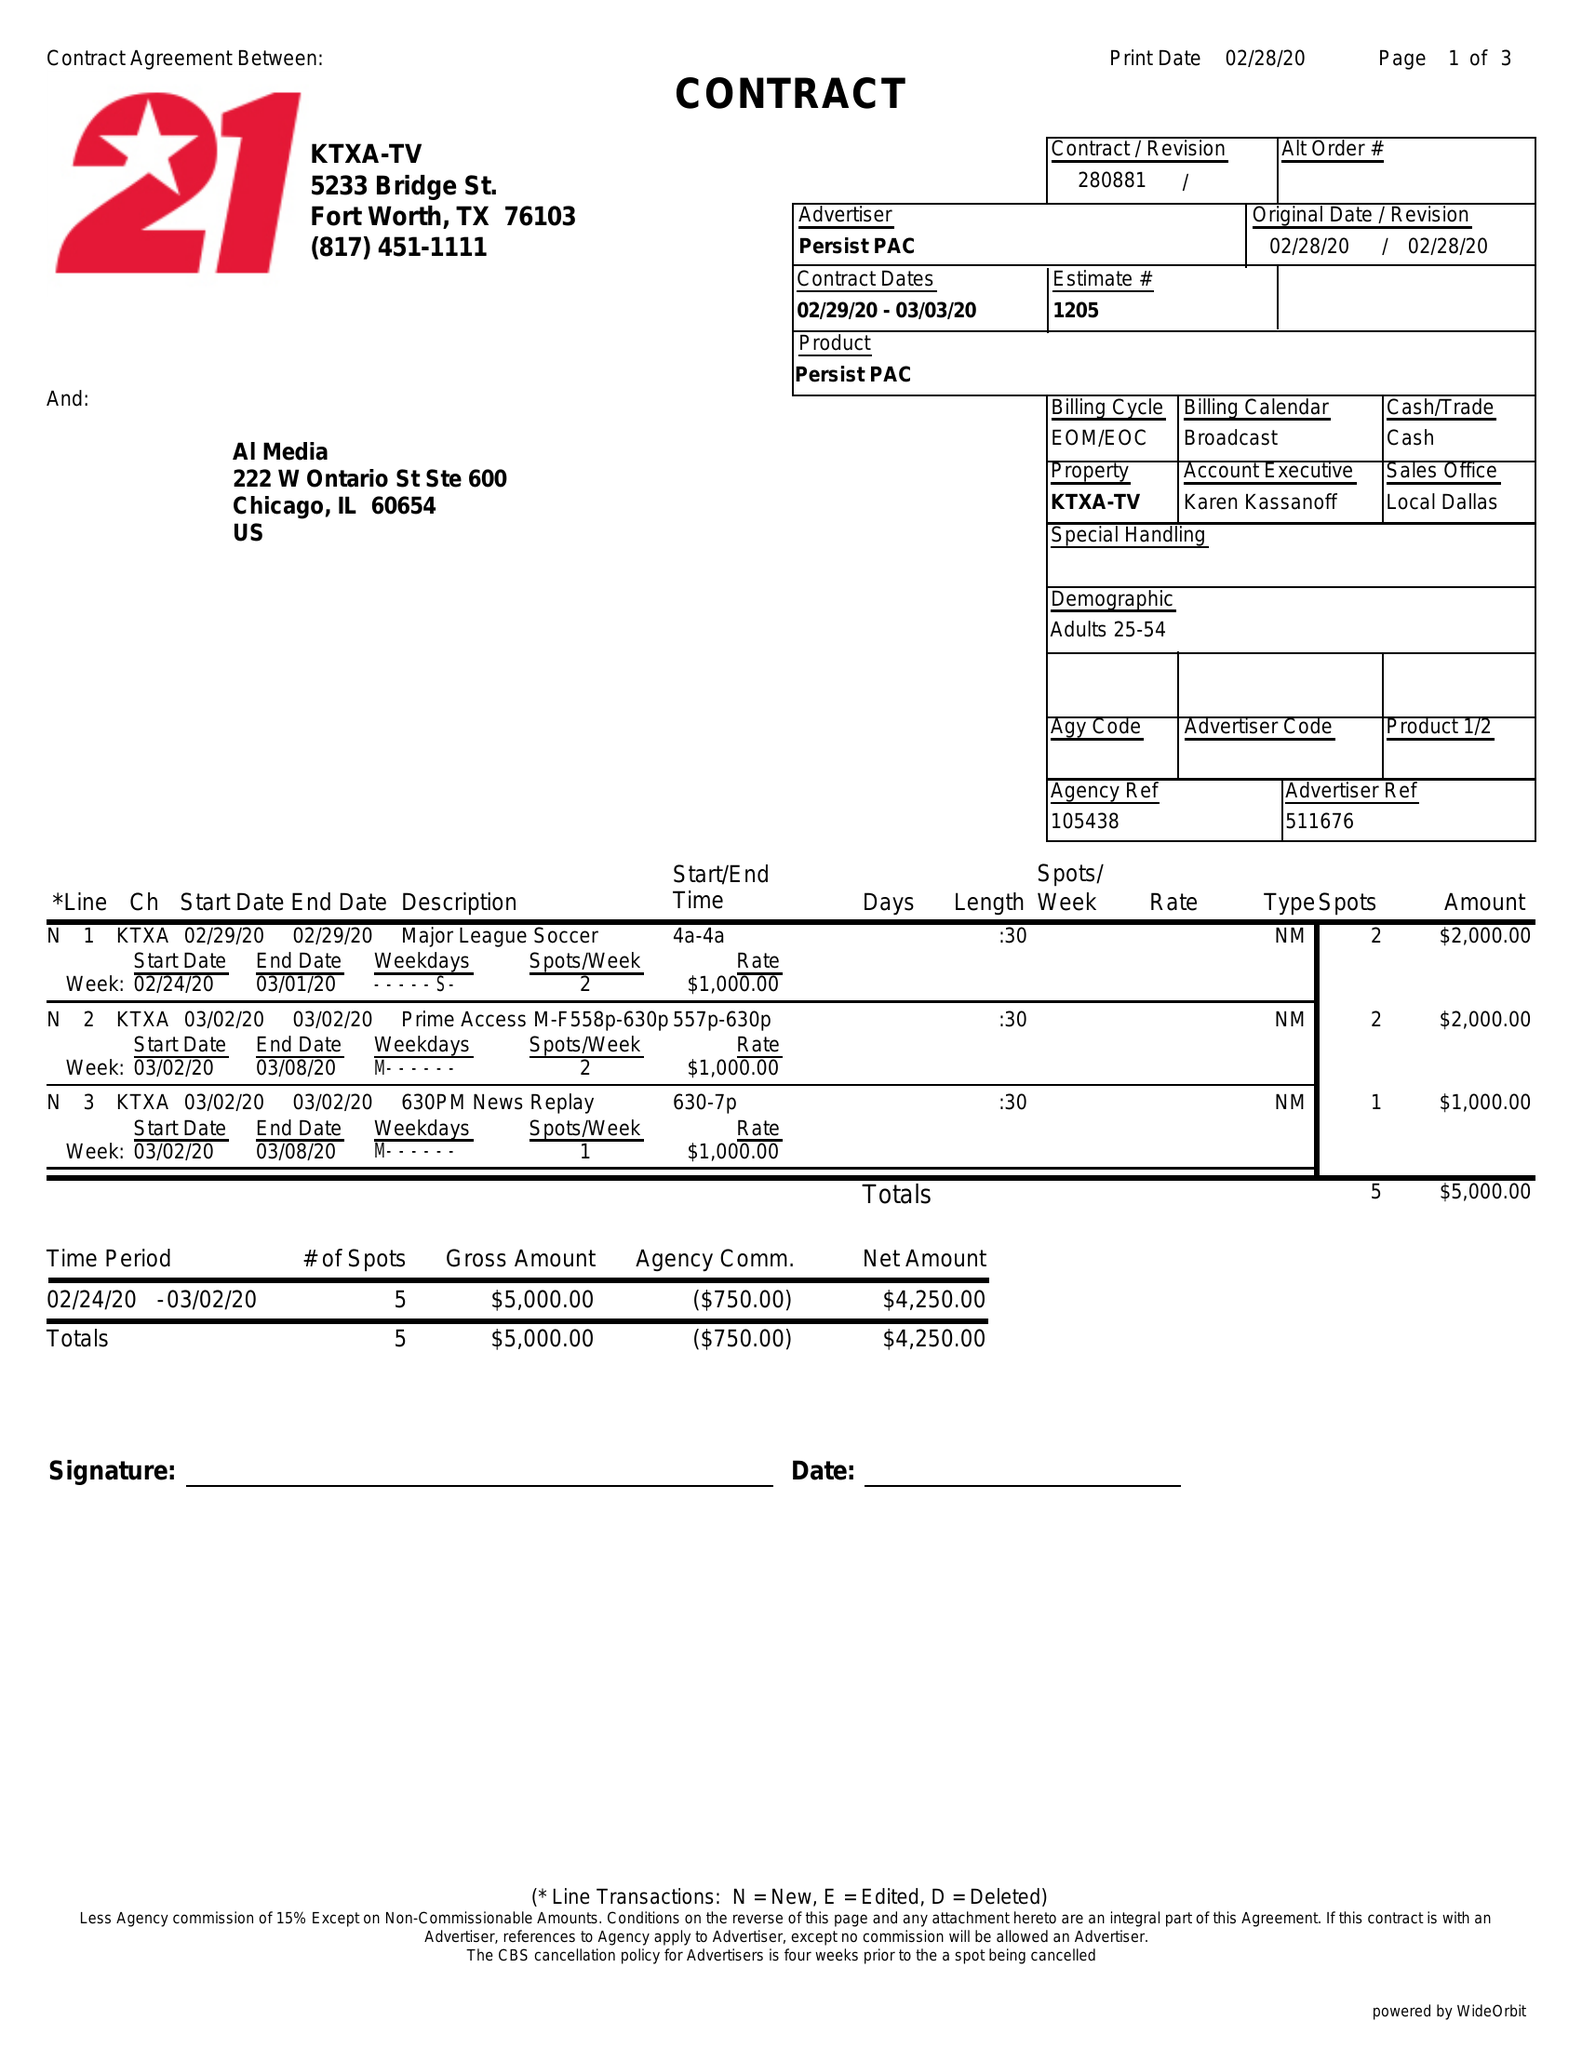What is the value for the advertiser?
Answer the question using a single word or phrase. PERSIST PAC 